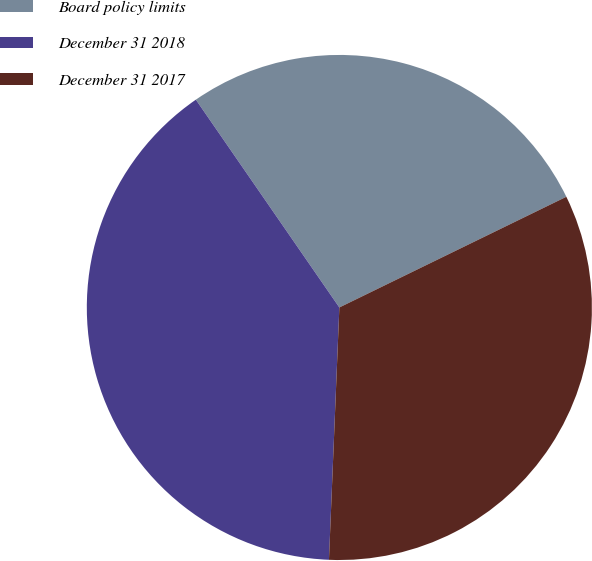<chart> <loc_0><loc_0><loc_500><loc_500><pie_chart><fcel>Board policy limits<fcel>December 31 2018<fcel>December 31 2017<nl><fcel>27.4%<fcel>39.73%<fcel>32.88%<nl></chart> 